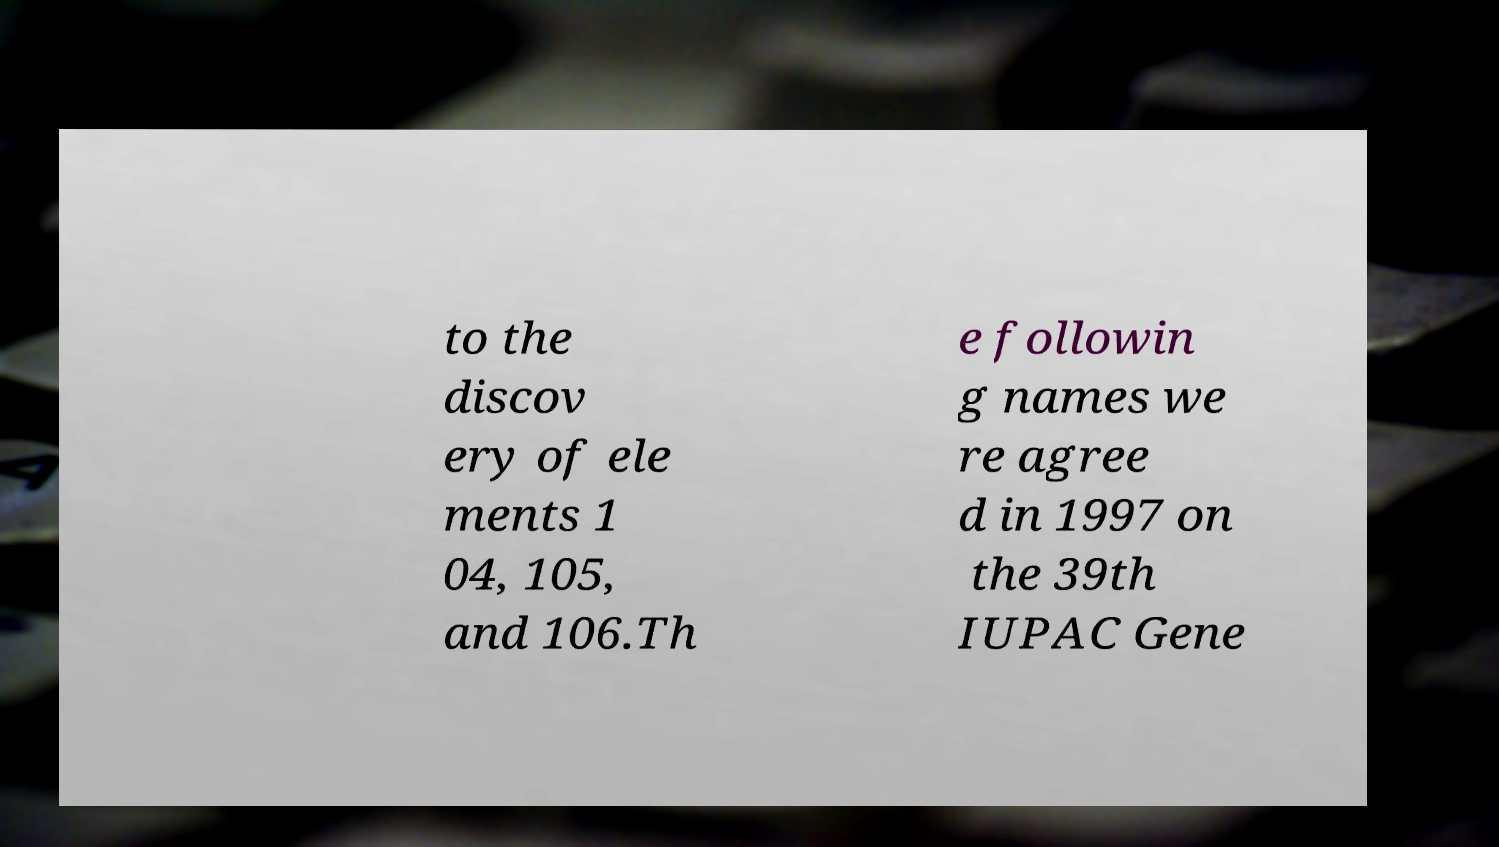For documentation purposes, I need the text within this image transcribed. Could you provide that? to the discov ery of ele ments 1 04, 105, and 106.Th e followin g names we re agree d in 1997 on the 39th IUPAC Gene 